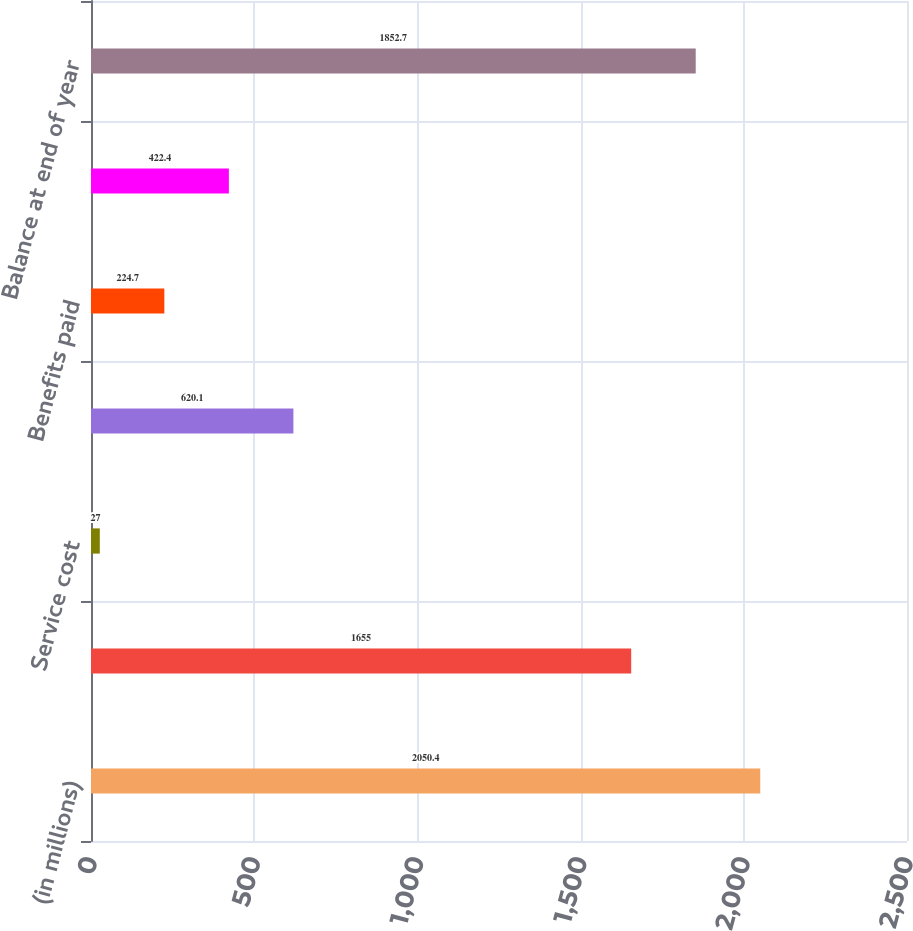Convert chart. <chart><loc_0><loc_0><loc_500><loc_500><bar_chart><fcel>(in millions)<fcel>Balance at beginning of year<fcel>Service cost<fcel>Interest cost<fcel>Benefits paid<fcel>Actuarial (gain) loss<fcel>Balance at end of year<nl><fcel>2050.4<fcel>1655<fcel>27<fcel>620.1<fcel>224.7<fcel>422.4<fcel>1852.7<nl></chart> 